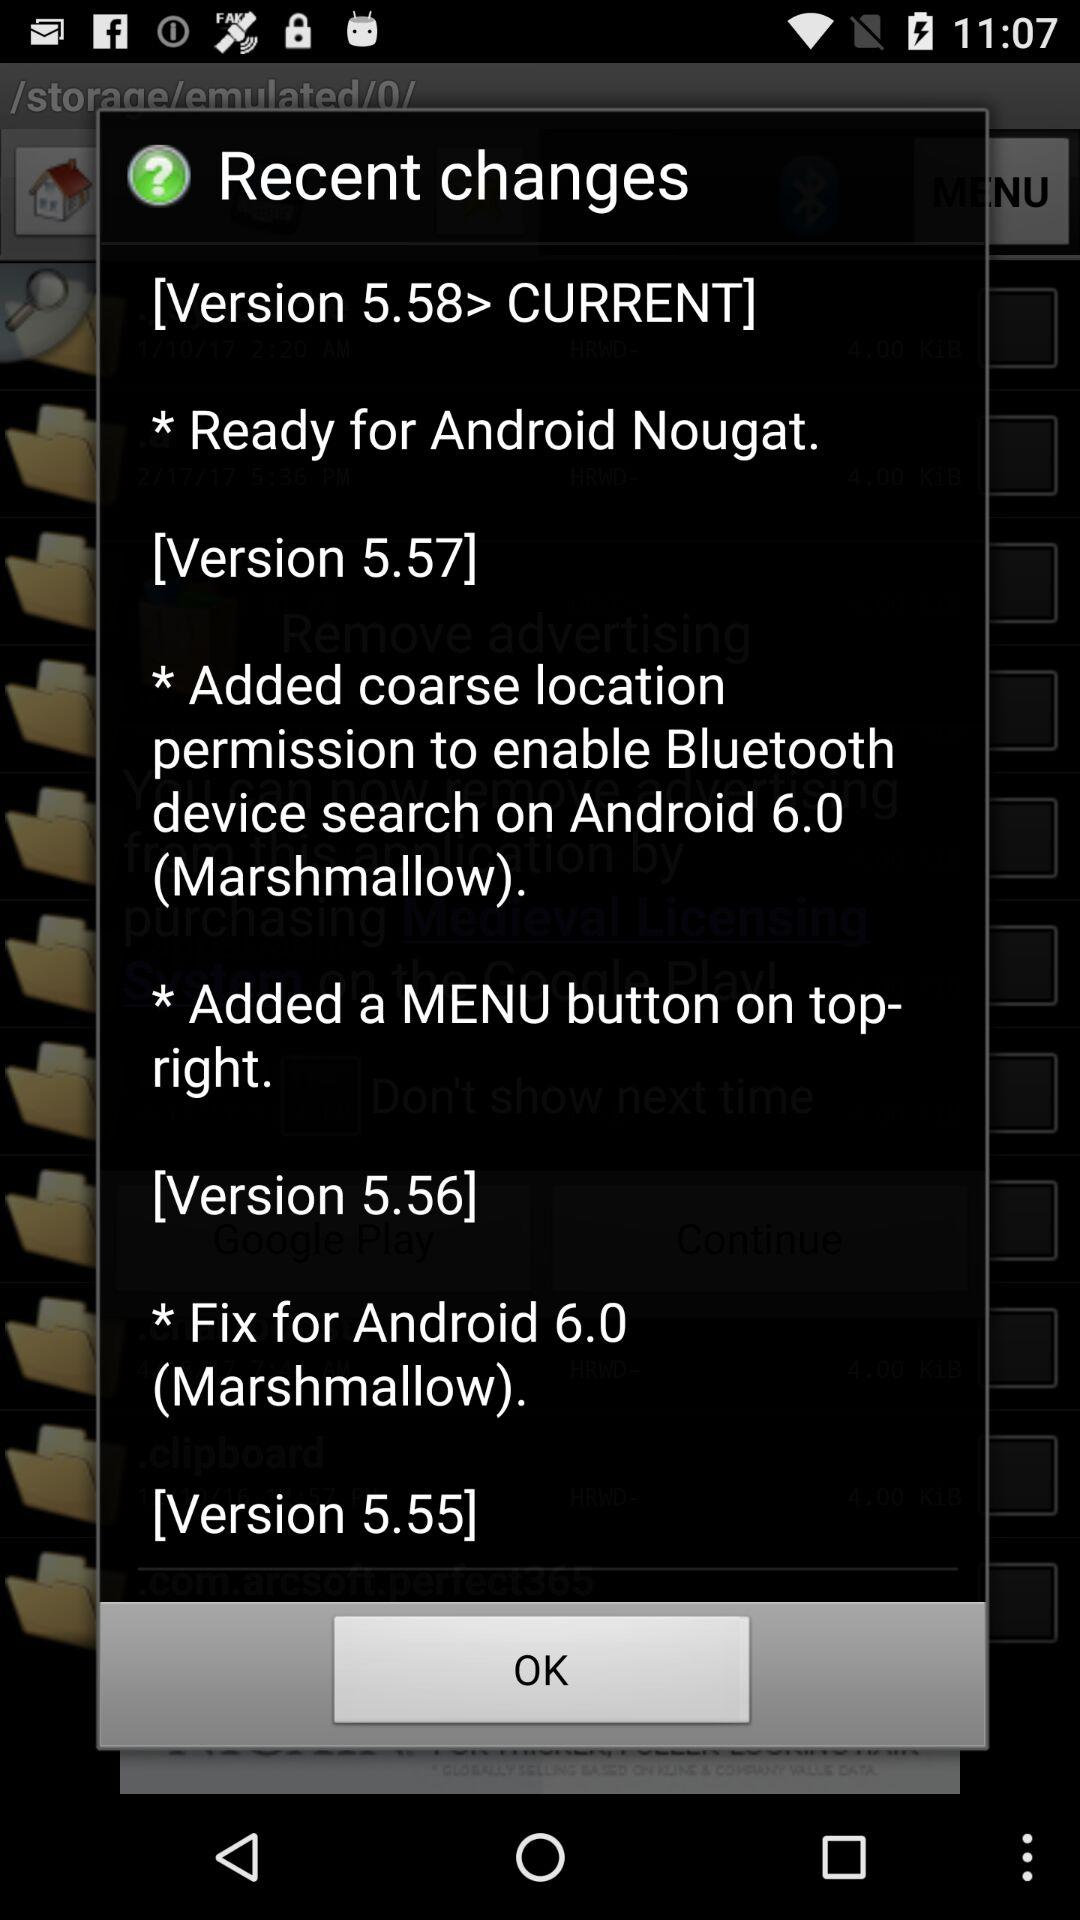In what version is the change "Ready for Android Nougat" made? The version is 5.58. 